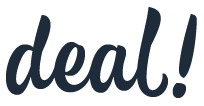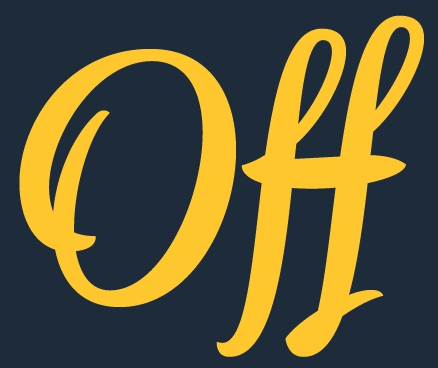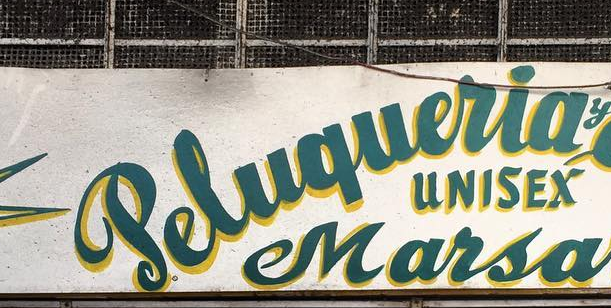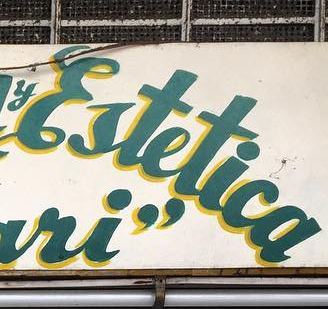What words can you see in these images in sequence, separated by a semicolon? deal!; Off; Peluqueria; Ertetica 